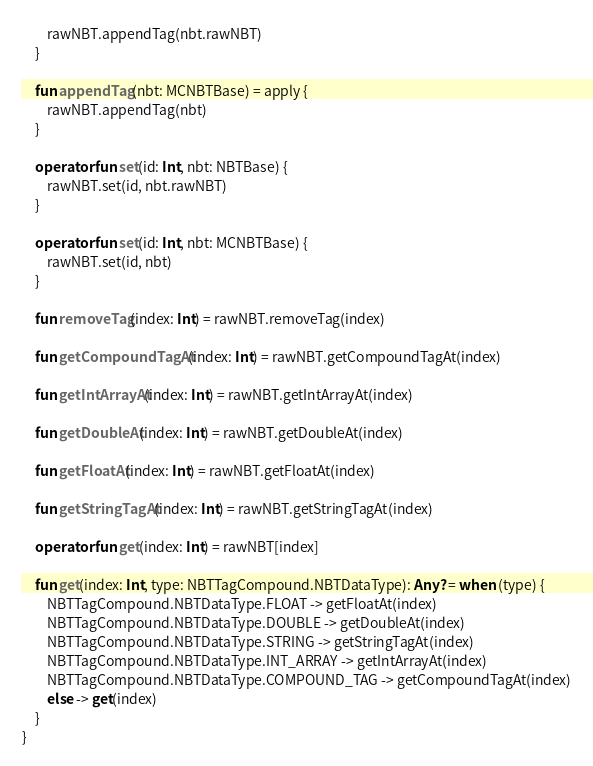<code> <loc_0><loc_0><loc_500><loc_500><_Kotlin_>        rawNBT.appendTag(nbt.rawNBT)
    }

    fun appendTag(nbt: MCNBTBase) = apply {
        rawNBT.appendTag(nbt)
    }

    operator fun set(id: Int, nbt: NBTBase) {
        rawNBT.set(id, nbt.rawNBT)
    }

    operator fun set(id: Int, nbt: MCNBTBase) {
        rawNBT.set(id, nbt)
    }

    fun removeTag(index: Int) = rawNBT.removeTag(index)

    fun getCompoundTagAt(index: Int) = rawNBT.getCompoundTagAt(index)

    fun getIntArrayAt(index: Int) = rawNBT.getIntArrayAt(index)

    fun getDoubleAt(index: Int) = rawNBT.getDoubleAt(index)

    fun getFloatAt(index: Int) = rawNBT.getFloatAt(index)

    fun getStringTagAt(index: Int) = rawNBT.getStringTagAt(index)

    operator fun get(index: Int) = rawNBT[index]

    fun get(index: Int, type: NBTTagCompound.NBTDataType): Any? = when (type) {
        NBTTagCompound.NBTDataType.FLOAT -> getFloatAt(index)
        NBTTagCompound.NBTDataType.DOUBLE -> getDoubleAt(index)
        NBTTagCompound.NBTDataType.STRING -> getStringTagAt(index)
        NBTTagCompound.NBTDataType.INT_ARRAY -> getIntArrayAt(index)
        NBTTagCompound.NBTDataType.COMPOUND_TAG -> getCompoundTagAt(index)
        else -> get(index)
    }
}</code> 